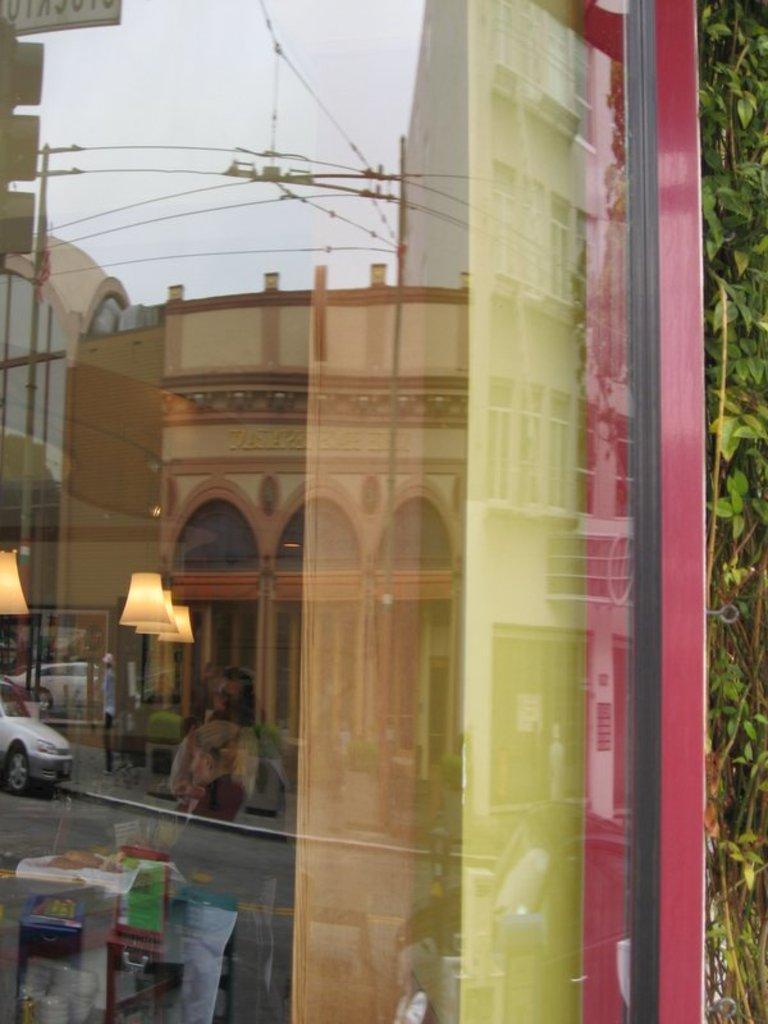Could you give a brief overview of what you see in this image? In the picture I can see the glass door on which I can see the reflection of buildings, wires and the sky. Here I can see ceiling lights and the trees on the right side of the image. 